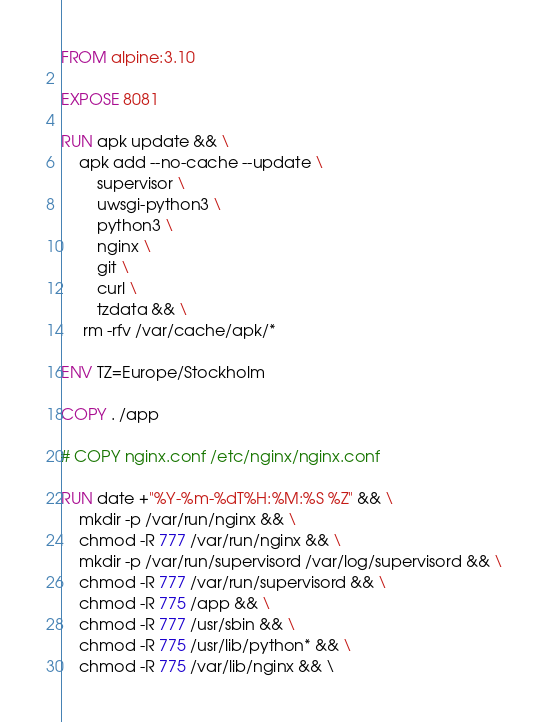Convert code to text. <code><loc_0><loc_0><loc_500><loc_500><_Dockerfile_>FROM alpine:3.10

EXPOSE 8081

RUN apk update && \
    apk add --no-cache --update \
        supervisor \
        uwsgi-python3 \
        python3 \
        nginx \
        git \
        curl \
        tzdata && \
     rm -rfv /var/cache/apk/*

ENV TZ=Europe/Stockholm

COPY . /app

# COPY nginx.conf /etc/nginx/nginx.conf

RUN date +"%Y-%m-%dT%H:%M:%S %Z" && \
    mkdir -p /var/run/nginx && \
    chmod -R 777 /var/run/nginx && \ 
    mkdir -p /var/run/supervisord /var/log/supervisord && \
    chmod -R 777 /var/run/supervisord && \
    chmod -R 775 /app && \
    chmod -R 777 /usr/sbin && \
    chmod -R 775 /usr/lib/python* && \
    chmod -R 775 /var/lib/nginx && \</code> 